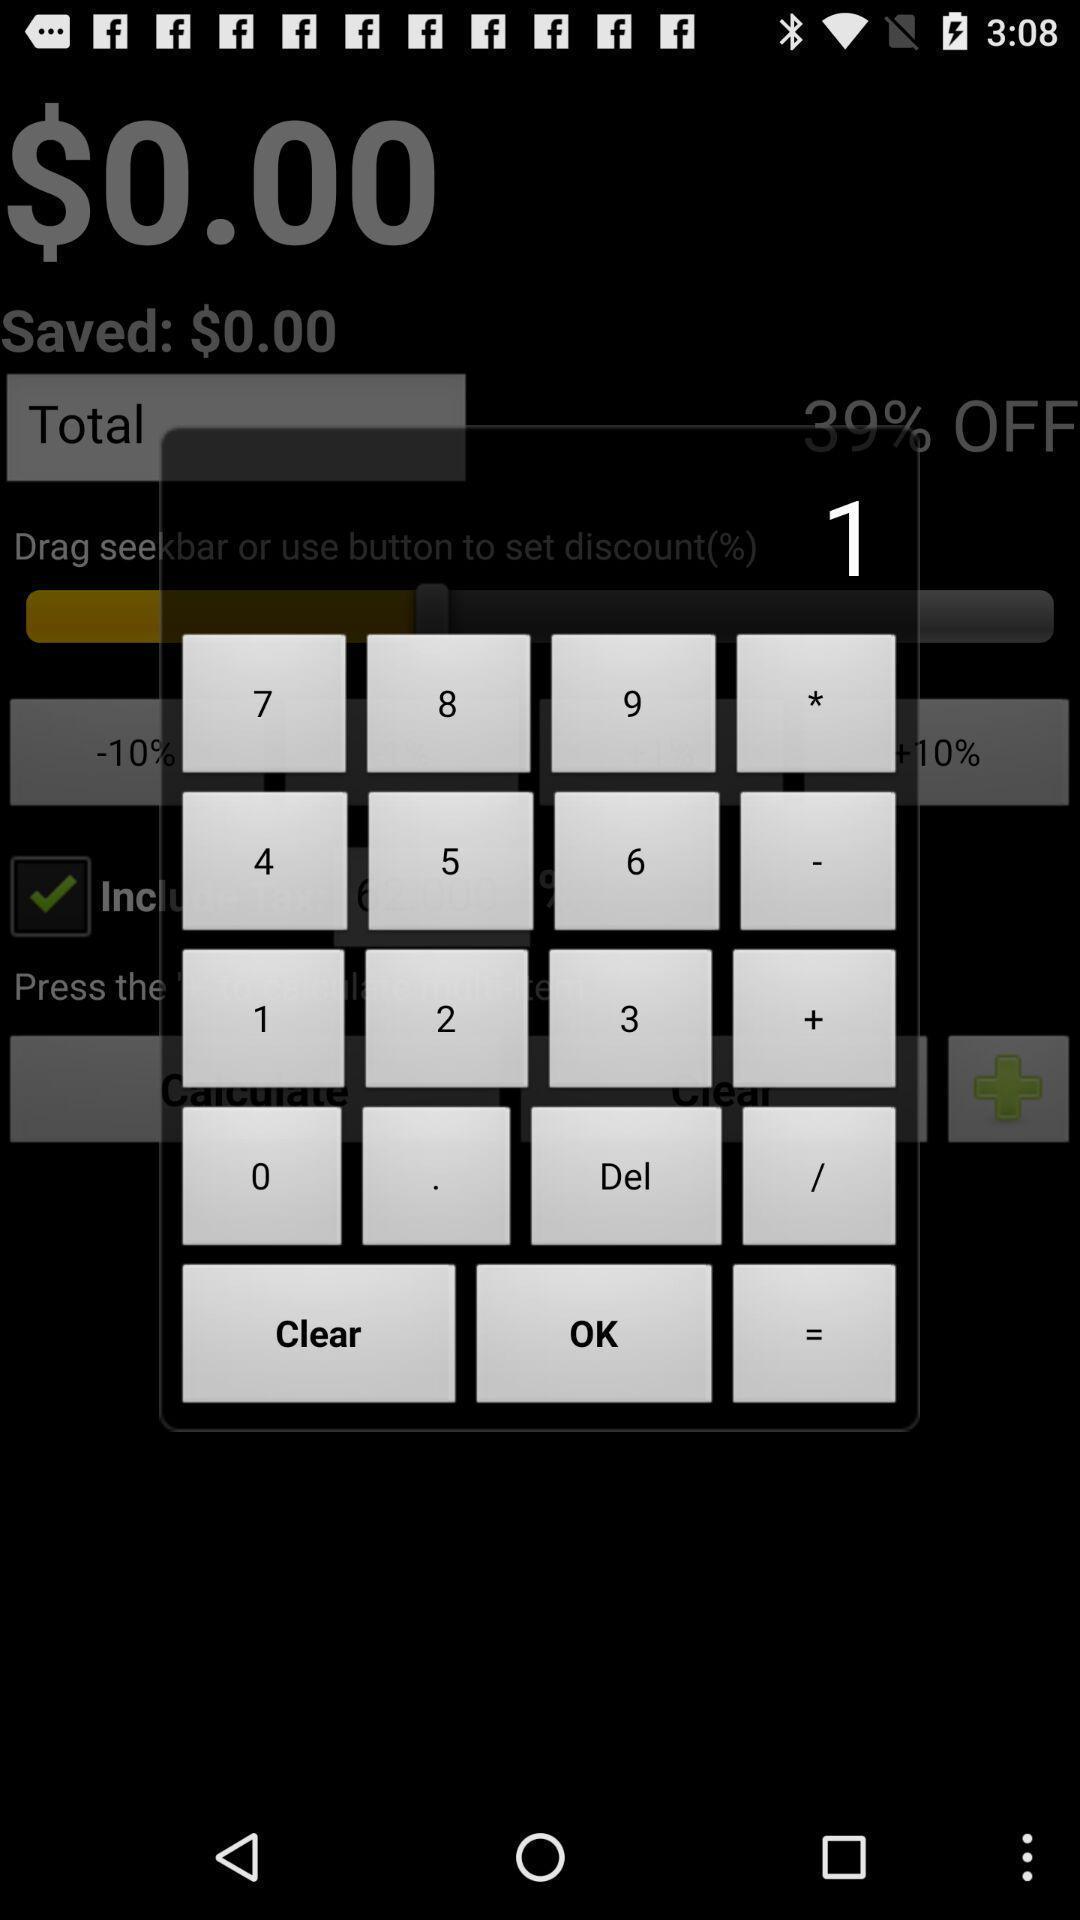Please provide a description for this image. Pop-up shows to enter numbers. 